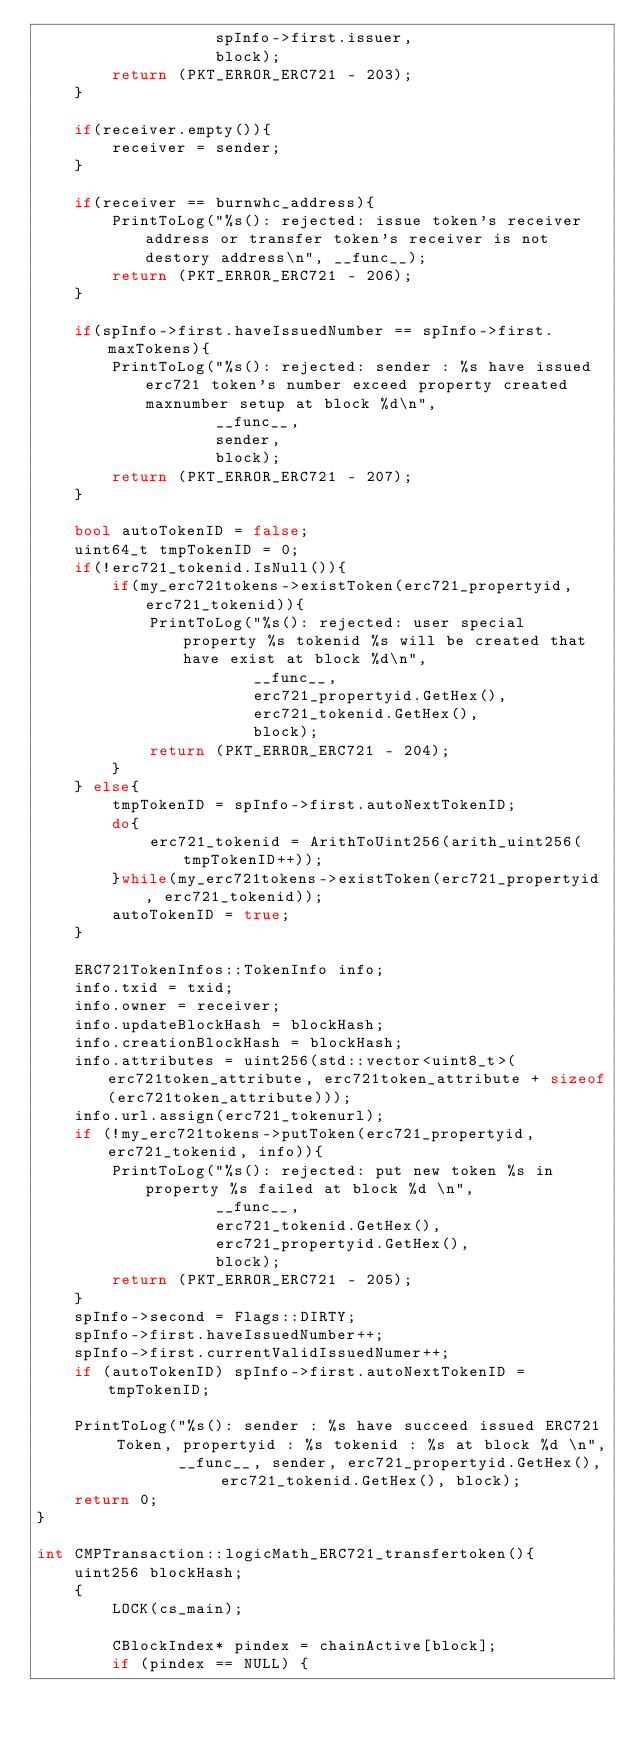<code> <loc_0><loc_0><loc_500><loc_500><_C++_>                   spInfo->first.issuer,
                   block);
        return (PKT_ERROR_ERC721 - 203);
    }

    if(receiver.empty()){
        receiver = sender;
    }

    if(receiver == burnwhc_address){
        PrintToLog("%s(): rejected: issue token's receiver address or transfer token's receiver is not destory address\n", __func__);
        return (PKT_ERROR_ERC721 - 206);
    }

    if(spInfo->first.haveIssuedNumber == spInfo->first.maxTokens){
        PrintToLog("%s(): rejected: sender : %s have issued erc721 token's number exceed property created maxnumber setup at block %d\n",
                   __func__,
                   sender,
                   block);
        return (PKT_ERROR_ERC721 - 207);
    }

    bool autoTokenID = false;
    uint64_t tmpTokenID = 0;
    if(!erc721_tokenid.IsNull()){
        if(my_erc721tokens->existToken(erc721_propertyid, erc721_tokenid)){
            PrintToLog("%s(): rejected: user special property %s tokenid %s will be created that have exist at block %d\n",
                       __func__,
                       erc721_propertyid.GetHex(),
                       erc721_tokenid.GetHex(),
                       block);
            return (PKT_ERROR_ERC721 - 204);
        }
    } else{
        tmpTokenID = spInfo->first.autoNextTokenID;
        do{
            erc721_tokenid = ArithToUint256(arith_uint256(tmpTokenID++));
        }while(my_erc721tokens->existToken(erc721_propertyid, erc721_tokenid));
        autoTokenID = true;
    }

    ERC721TokenInfos::TokenInfo info;
    info.txid = txid;
    info.owner = receiver;
    info.updateBlockHash = blockHash;
    info.creationBlockHash = blockHash;
    info.attributes = uint256(std::vector<uint8_t>(erc721token_attribute, erc721token_attribute + sizeof(erc721token_attribute)));
    info.url.assign(erc721_tokenurl);
    if (!my_erc721tokens->putToken(erc721_propertyid, erc721_tokenid, info)){
        PrintToLog("%s(): rejected: put new token %s in property %s failed at block %d \n",
                   __func__,
                   erc721_tokenid.GetHex(),
                   erc721_propertyid.GetHex(),
                   block);
        return (PKT_ERROR_ERC721 - 205);
    }
    spInfo->second = Flags::DIRTY;
    spInfo->first.haveIssuedNumber++;
    spInfo->first.currentValidIssuedNumer++;
    if (autoTokenID) spInfo->first.autoNextTokenID = tmpTokenID;

    PrintToLog("%s(): sender : %s have succeed issued ERC721 Token, propertyid : %s tokenid : %s at block %d \n",
               __func__, sender, erc721_propertyid.GetHex(), erc721_tokenid.GetHex(), block);
    return 0;
}

int CMPTransaction::logicMath_ERC721_transfertoken(){
    uint256 blockHash;
    {
        LOCK(cs_main);

        CBlockIndex* pindex = chainActive[block];
        if (pindex == NULL) {</code> 